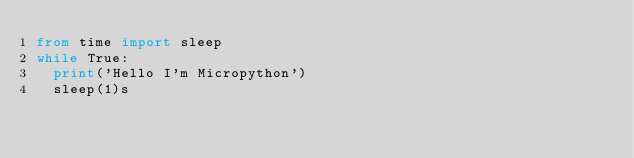Convert code to text. <code><loc_0><loc_0><loc_500><loc_500><_Python_>from time import sleep
while True:
  print('Hello I'm Micropython')
  sleep(1)s
</code> 